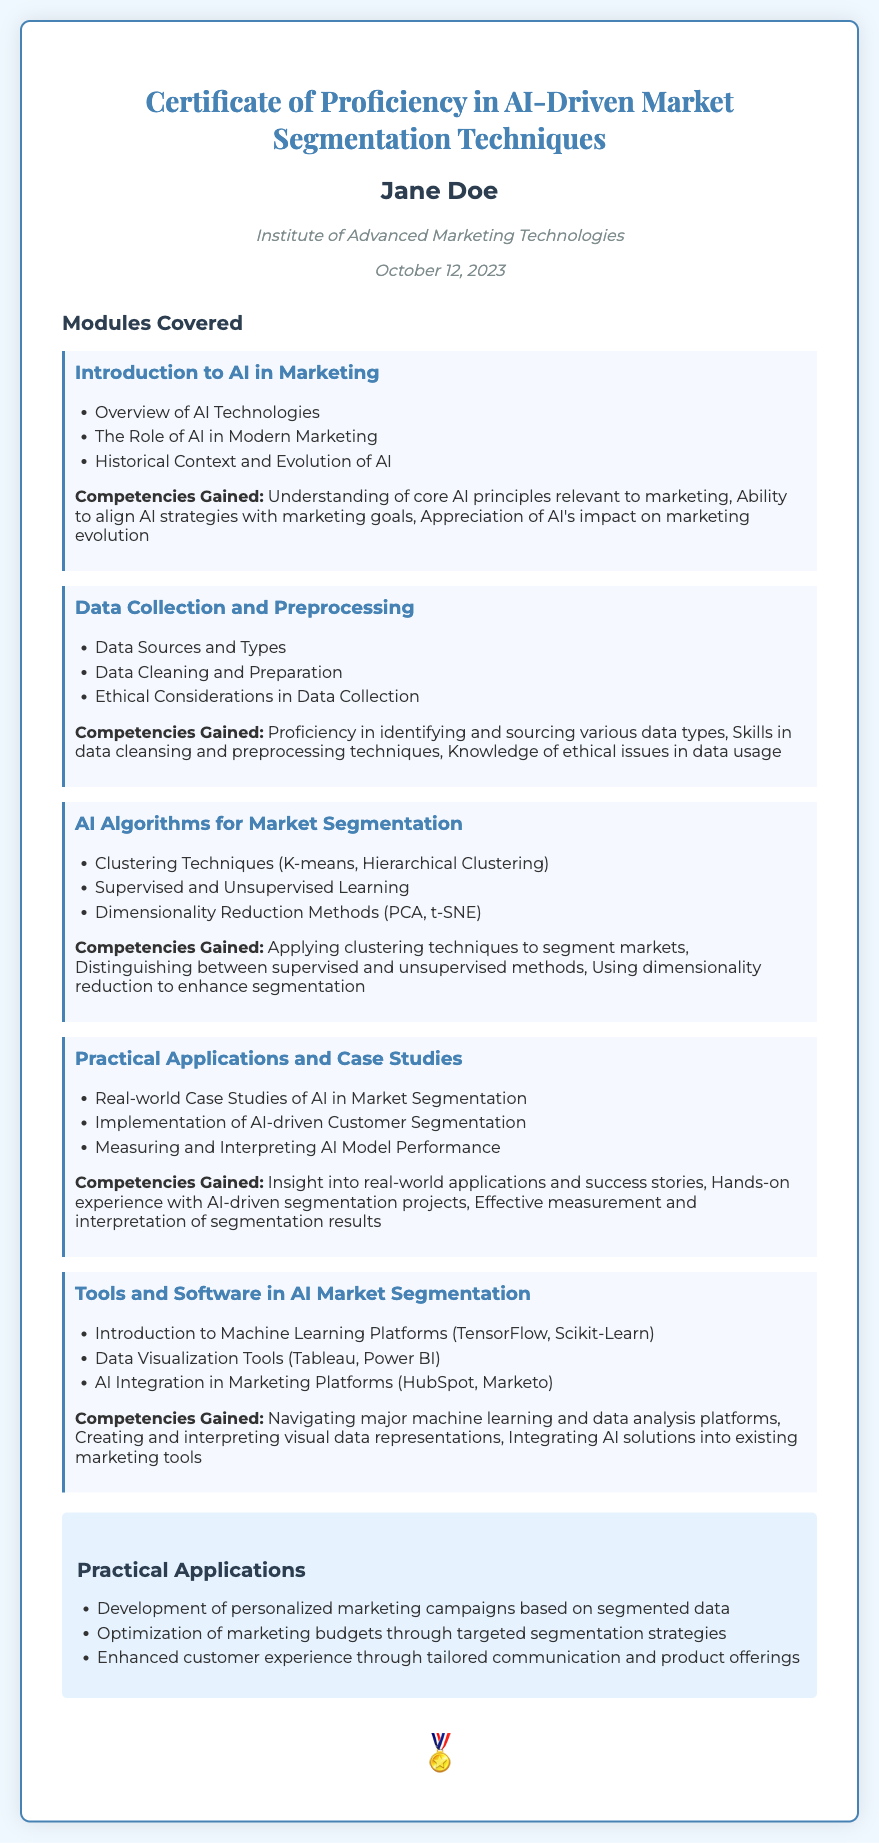What is the title of the certificate? The title of the certificate is prominently displayed at the top of the document.
Answer: Certificate of Proficiency in AI-Driven Market Segmentation Techniques Who is the holder of the certificate? The holder's name is presented below the title.
Answer: Jane Doe What institution issued the certificate? The issuing institution is noted in the document.
Answer: Institute of Advanced Marketing Technologies When was the certificate issued? The date of issue is listed in the document.
Answer: October 12, 2023 How many modules are covered in the certificate? The document lists each module covered in the course.
Answer: Five Which module covers data visualization tools? This module is specifically listed under its name and details.
Answer: Tools and Software in AI Market Segmentation What is one competency gained from the AI Algorithms for Market Segmentation module? The document provides specific competencies gained from each module.
Answer: Applying clustering techniques to segment markets Name one practical application mentioned in the document. The practical applications section lists several uses of the knowledge gained.
Answer: Development of personalized marketing campaigns based on segmented data What is the color of the border of the certificate? The visual design of the certificate specifies a color for the border.
Answer: #4682b4 